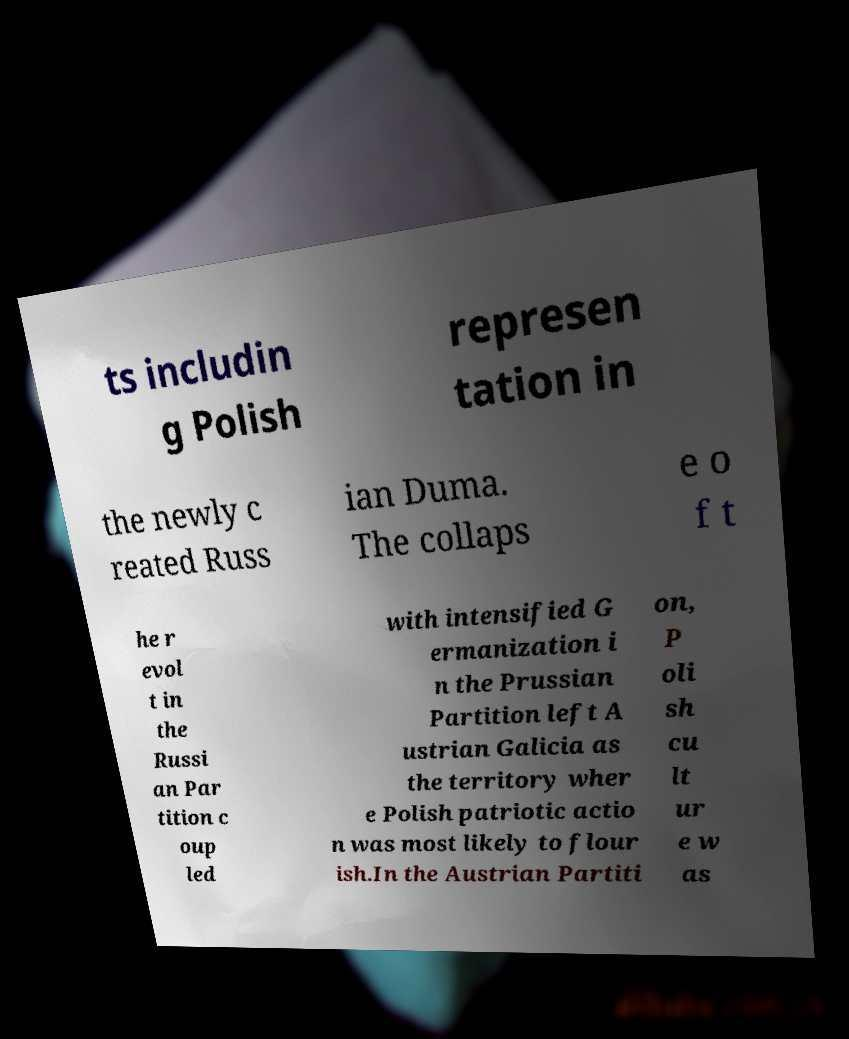Please identify and transcribe the text found in this image. ts includin g Polish represen tation in the newly c reated Russ ian Duma. The collaps e o f t he r evol t in the Russi an Par tition c oup led with intensified G ermanization i n the Prussian Partition left A ustrian Galicia as the territory wher e Polish patriotic actio n was most likely to flour ish.In the Austrian Partiti on, P oli sh cu lt ur e w as 